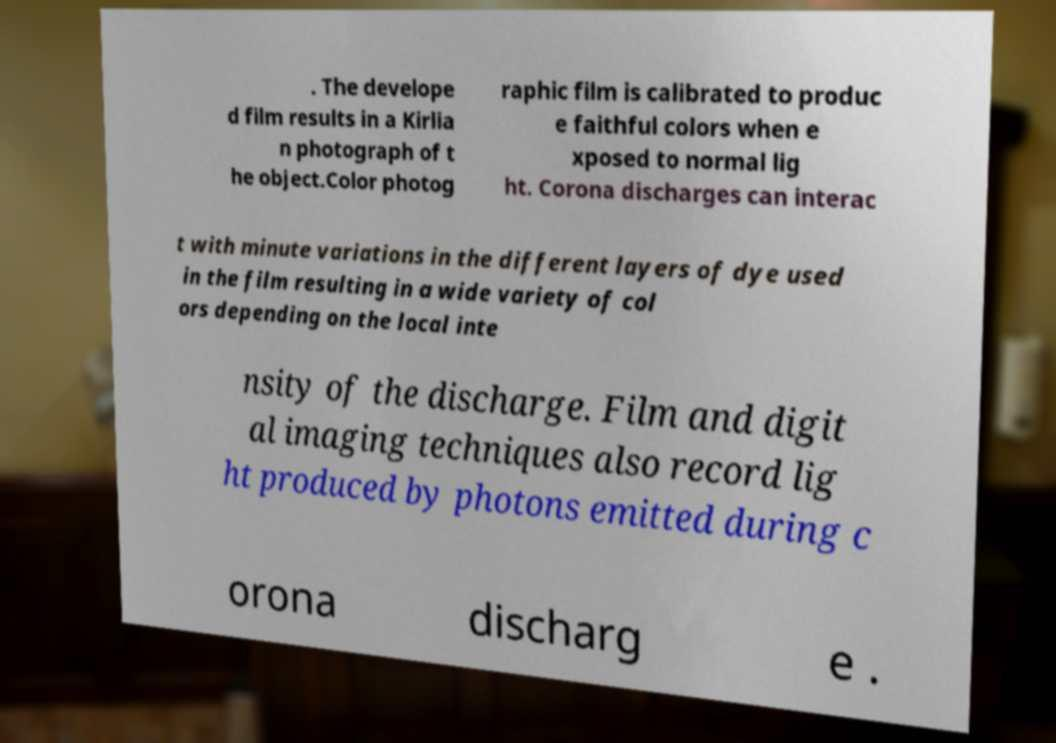Please read and relay the text visible in this image. What does it say? . The develope d film results in a Kirlia n photograph of t he object.Color photog raphic film is calibrated to produc e faithful colors when e xposed to normal lig ht. Corona discharges can interac t with minute variations in the different layers of dye used in the film resulting in a wide variety of col ors depending on the local inte nsity of the discharge. Film and digit al imaging techniques also record lig ht produced by photons emitted during c orona discharg e . 